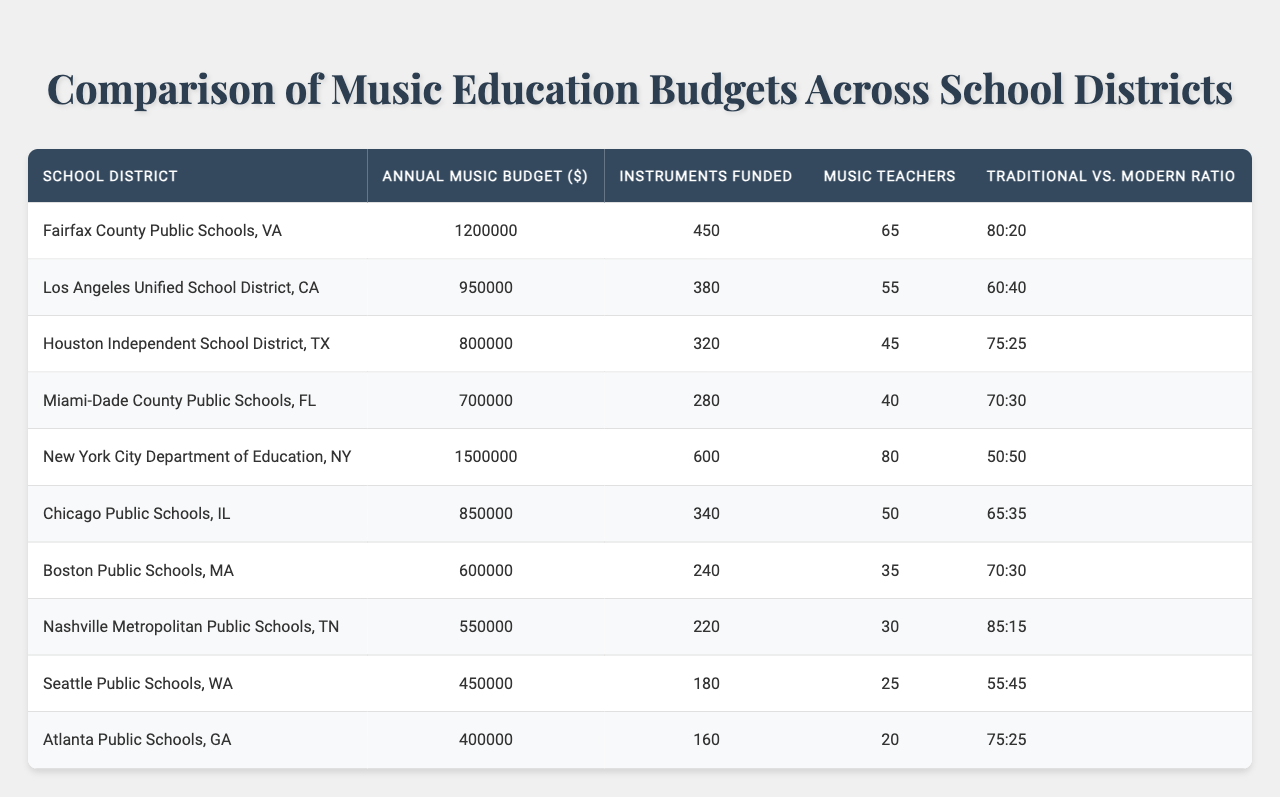What is the highest annual music budget among the listed school districts? The annual music budgets are listed for each school district. By comparing all the values, the highest budget is $1,500,000 from the New York City Department of Education, NY.
Answer: $1,500,000 How many instruments are funded in Fairfax County Public Schools, VA? The table indicates that Fairfax County Public Schools funds 450 instruments.
Answer: 450 Which school district has the lowest number of music teachers? By reviewing the column for music teachers, Nashville Metropolitan Public Schools has the lowest count at 30.
Answer: 30 What is the ratio of traditional to modern music in the Miami-Dade County Public Schools? The table specifies that the ratio of traditional to modern music for Miami-Dade County Public Schools is 70:30.
Answer: 70:30 How much more does the New York City Department of Education spend on its music budget compared to the Atlanta Public Schools? The budget for New York City is $1,500,000 and for Atlanta is $400,000. The difference is $1,500,000 - $400,000 = $1,100,000.
Answer: $1,100,000 What is the average budget of the top three school districts in terms of annual music budget? The top three budgets are $1,500,000 (NY), $1,200,000 (Fairfax), and $950,000 (LA). The average is ($1,500,000 + $1,200,000 + $950,000) / 3 = $1,216,667.
Answer: $1,216,667 Is there a school district that has a higher ratio of traditional to modern music than Houston Independent School District? Houston's ratio is 75:25. By comparing, Fairfax County and Nashville both have ratios of 80:20 and 85:15 respectively, indicating both are higher.
Answer: Yes Which school district has more instruments funded than Chicago Public Schools? Chicago Public Schools funds 340 instruments. By examining the data, New York City, Fairfax County, and Los Angeles all fund more instruments: 600, 450, and 380 respectively.
Answer: New York City, Fairfax County, Los Angeles What is the total amount spent on music budgets by the five districts with the lowest budgets? The five districts with the lowest budgets are Atlanta ($400,000), Seattle ($450,000), Nashville ($550,000), Boston ($600,000), and Miami-Dade ($700,000). Adding these together gives $400,000 + $450,000 + $550,000 + $600,000 + $700,000 = $2,700,000.
Answer: $2,700,000 What percentage of the total music budget do the music teachers in New York City represent? New York City has a budget of $1,500,000 and employs 80 teachers. The total budget across all districts sums up to $7,550,000, calculated by adding all the provided budgets. The percentage is (1,500,000 / 7,550,000) * 100 = 19.87%.
Answer: 19.87% 